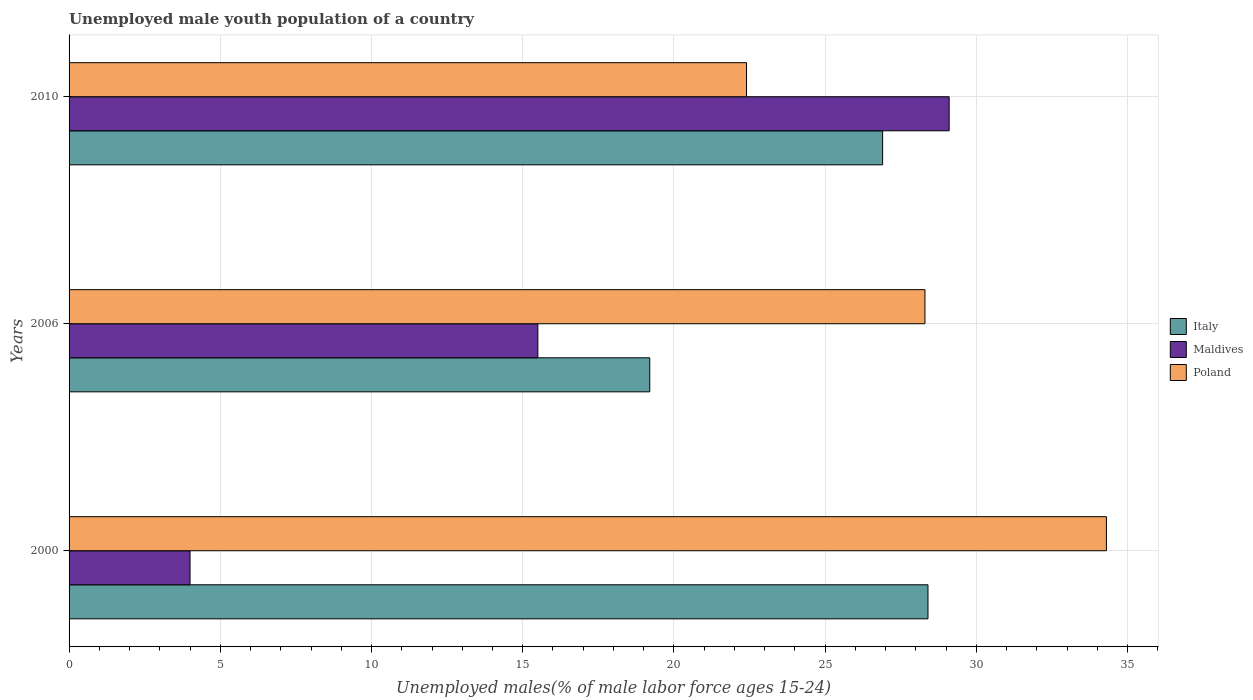Are the number of bars per tick equal to the number of legend labels?
Your answer should be compact. Yes. Are the number of bars on each tick of the Y-axis equal?
Provide a short and direct response. Yes. How many bars are there on the 3rd tick from the top?
Offer a terse response. 3. How many bars are there on the 1st tick from the bottom?
Make the answer very short. 3. In how many cases, is the number of bars for a given year not equal to the number of legend labels?
Ensure brevity in your answer.  0. What is the percentage of unemployed male youth population in Maldives in 2010?
Your answer should be compact. 29.1. Across all years, what is the maximum percentage of unemployed male youth population in Maldives?
Provide a short and direct response. 29.1. Across all years, what is the minimum percentage of unemployed male youth population in Poland?
Your answer should be very brief. 22.4. In which year was the percentage of unemployed male youth population in Maldives maximum?
Provide a short and direct response. 2010. What is the total percentage of unemployed male youth population in Maldives in the graph?
Give a very brief answer. 48.6. What is the difference between the percentage of unemployed male youth population in Italy in 2006 and that in 2010?
Give a very brief answer. -7.7. What is the difference between the percentage of unemployed male youth population in Maldives in 2010 and the percentage of unemployed male youth population in Poland in 2006?
Your answer should be very brief. 0.8. What is the average percentage of unemployed male youth population in Poland per year?
Keep it short and to the point. 28.33. In the year 2000, what is the difference between the percentage of unemployed male youth population in Maldives and percentage of unemployed male youth population in Italy?
Make the answer very short. -24.4. What is the ratio of the percentage of unemployed male youth population in Poland in 2006 to that in 2010?
Offer a very short reply. 1.26. Is the percentage of unemployed male youth population in Italy in 2006 less than that in 2010?
Your response must be concise. Yes. Is the difference between the percentage of unemployed male youth population in Maldives in 2000 and 2010 greater than the difference between the percentage of unemployed male youth population in Italy in 2000 and 2010?
Offer a terse response. No. What is the difference between the highest and the second highest percentage of unemployed male youth population in Italy?
Keep it short and to the point. 1.5. What is the difference between the highest and the lowest percentage of unemployed male youth population in Poland?
Offer a terse response. 11.9. What does the 2nd bar from the top in 2006 represents?
Your answer should be compact. Maldives. How many bars are there?
Your response must be concise. 9. How many years are there in the graph?
Provide a succinct answer. 3. Does the graph contain grids?
Provide a short and direct response. Yes. Where does the legend appear in the graph?
Ensure brevity in your answer.  Center right. How many legend labels are there?
Offer a terse response. 3. How are the legend labels stacked?
Provide a succinct answer. Vertical. What is the title of the graph?
Your answer should be very brief. Unemployed male youth population of a country. What is the label or title of the X-axis?
Provide a short and direct response. Unemployed males(% of male labor force ages 15-24). What is the Unemployed males(% of male labor force ages 15-24) in Italy in 2000?
Keep it short and to the point. 28.4. What is the Unemployed males(% of male labor force ages 15-24) of Poland in 2000?
Provide a succinct answer. 34.3. What is the Unemployed males(% of male labor force ages 15-24) of Italy in 2006?
Offer a terse response. 19.2. What is the Unemployed males(% of male labor force ages 15-24) in Maldives in 2006?
Offer a very short reply. 15.5. What is the Unemployed males(% of male labor force ages 15-24) of Poland in 2006?
Provide a short and direct response. 28.3. What is the Unemployed males(% of male labor force ages 15-24) in Italy in 2010?
Make the answer very short. 26.9. What is the Unemployed males(% of male labor force ages 15-24) in Maldives in 2010?
Offer a very short reply. 29.1. What is the Unemployed males(% of male labor force ages 15-24) in Poland in 2010?
Your response must be concise. 22.4. Across all years, what is the maximum Unemployed males(% of male labor force ages 15-24) in Italy?
Your answer should be very brief. 28.4. Across all years, what is the maximum Unemployed males(% of male labor force ages 15-24) of Maldives?
Ensure brevity in your answer.  29.1. Across all years, what is the maximum Unemployed males(% of male labor force ages 15-24) of Poland?
Provide a succinct answer. 34.3. Across all years, what is the minimum Unemployed males(% of male labor force ages 15-24) in Italy?
Give a very brief answer. 19.2. Across all years, what is the minimum Unemployed males(% of male labor force ages 15-24) in Maldives?
Provide a succinct answer. 4. Across all years, what is the minimum Unemployed males(% of male labor force ages 15-24) in Poland?
Ensure brevity in your answer.  22.4. What is the total Unemployed males(% of male labor force ages 15-24) in Italy in the graph?
Give a very brief answer. 74.5. What is the total Unemployed males(% of male labor force ages 15-24) of Maldives in the graph?
Offer a very short reply. 48.6. What is the difference between the Unemployed males(% of male labor force ages 15-24) of Maldives in 2000 and that in 2010?
Make the answer very short. -25.1. What is the difference between the Unemployed males(% of male labor force ages 15-24) of Poland in 2000 and that in 2010?
Make the answer very short. 11.9. What is the difference between the Unemployed males(% of male labor force ages 15-24) in Italy in 2006 and that in 2010?
Provide a succinct answer. -7.7. What is the difference between the Unemployed males(% of male labor force ages 15-24) in Italy in 2000 and the Unemployed males(% of male labor force ages 15-24) in Maldives in 2006?
Provide a succinct answer. 12.9. What is the difference between the Unemployed males(% of male labor force ages 15-24) of Italy in 2000 and the Unemployed males(% of male labor force ages 15-24) of Poland in 2006?
Provide a succinct answer. 0.1. What is the difference between the Unemployed males(% of male labor force ages 15-24) in Maldives in 2000 and the Unemployed males(% of male labor force ages 15-24) in Poland in 2006?
Give a very brief answer. -24.3. What is the difference between the Unemployed males(% of male labor force ages 15-24) of Italy in 2000 and the Unemployed males(% of male labor force ages 15-24) of Maldives in 2010?
Your response must be concise. -0.7. What is the difference between the Unemployed males(% of male labor force ages 15-24) in Italy in 2000 and the Unemployed males(% of male labor force ages 15-24) in Poland in 2010?
Provide a short and direct response. 6. What is the difference between the Unemployed males(% of male labor force ages 15-24) of Maldives in 2000 and the Unemployed males(% of male labor force ages 15-24) of Poland in 2010?
Provide a short and direct response. -18.4. What is the difference between the Unemployed males(% of male labor force ages 15-24) in Italy in 2006 and the Unemployed males(% of male labor force ages 15-24) in Poland in 2010?
Provide a succinct answer. -3.2. What is the average Unemployed males(% of male labor force ages 15-24) in Italy per year?
Offer a very short reply. 24.83. What is the average Unemployed males(% of male labor force ages 15-24) of Maldives per year?
Your answer should be very brief. 16.2. What is the average Unemployed males(% of male labor force ages 15-24) of Poland per year?
Offer a very short reply. 28.33. In the year 2000, what is the difference between the Unemployed males(% of male labor force ages 15-24) in Italy and Unemployed males(% of male labor force ages 15-24) in Maldives?
Your answer should be very brief. 24.4. In the year 2000, what is the difference between the Unemployed males(% of male labor force ages 15-24) of Maldives and Unemployed males(% of male labor force ages 15-24) of Poland?
Your response must be concise. -30.3. In the year 2006, what is the difference between the Unemployed males(% of male labor force ages 15-24) in Italy and Unemployed males(% of male labor force ages 15-24) in Maldives?
Make the answer very short. 3.7. In the year 2006, what is the difference between the Unemployed males(% of male labor force ages 15-24) of Maldives and Unemployed males(% of male labor force ages 15-24) of Poland?
Offer a terse response. -12.8. In the year 2010, what is the difference between the Unemployed males(% of male labor force ages 15-24) in Maldives and Unemployed males(% of male labor force ages 15-24) in Poland?
Give a very brief answer. 6.7. What is the ratio of the Unemployed males(% of male labor force ages 15-24) in Italy in 2000 to that in 2006?
Provide a succinct answer. 1.48. What is the ratio of the Unemployed males(% of male labor force ages 15-24) of Maldives in 2000 to that in 2006?
Offer a very short reply. 0.26. What is the ratio of the Unemployed males(% of male labor force ages 15-24) in Poland in 2000 to that in 2006?
Offer a very short reply. 1.21. What is the ratio of the Unemployed males(% of male labor force ages 15-24) in Italy in 2000 to that in 2010?
Keep it short and to the point. 1.06. What is the ratio of the Unemployed males(% of male labor force ages 15-24) of Maldives in 2000 to that in 2010?
Keep it short and to the point. 0.14. What is the ratio of the Unemployed males(% of male labor force ages 15-24) of Poland in 2000 to that in 2010?
Give a very brief answer. 1.53. What is the ratio of the Unemployed males(% of male labor force ages 15-24) in Italy in 2006 to that in 2010?
Provide a short and direct response. 0.71. What is the ratio of the Unemployed males(% of male labor force ages 15-24) in Maldives in 2006 to that in 2010?
Keep it short and to the point. 0.53. What is the ratio of the Unemployed males(% of male labor force ages 15-24) in Poland in 2006 to that in 2010?
Give a very brief answer. 1.26. What is the difference between the highest and the second highest Unemployed males(% of male labor force ages 15-24) of Maldives?
Offer a terse response. 13.6. What is the difference between the highest and the second highest Unemployed males(% of male labor force ages 15-24) in Poland?
Your answer should be compact. 6. What is the difference between the highest and the lowest Unemployed males(% of male labor force ages 15-24) in Italy?
Provide a succinct answer. 9.2. What is the difference between the highest and the lowest Unemployed males(% of male labor force ages 15-24) of Maldives?
Offer a very short reply. 25.1. What is the difference between the highest and the lowest Unemployed males(% of male labor force ages 15-24) in Poland?
Keep it short and to the point. 11.9. 